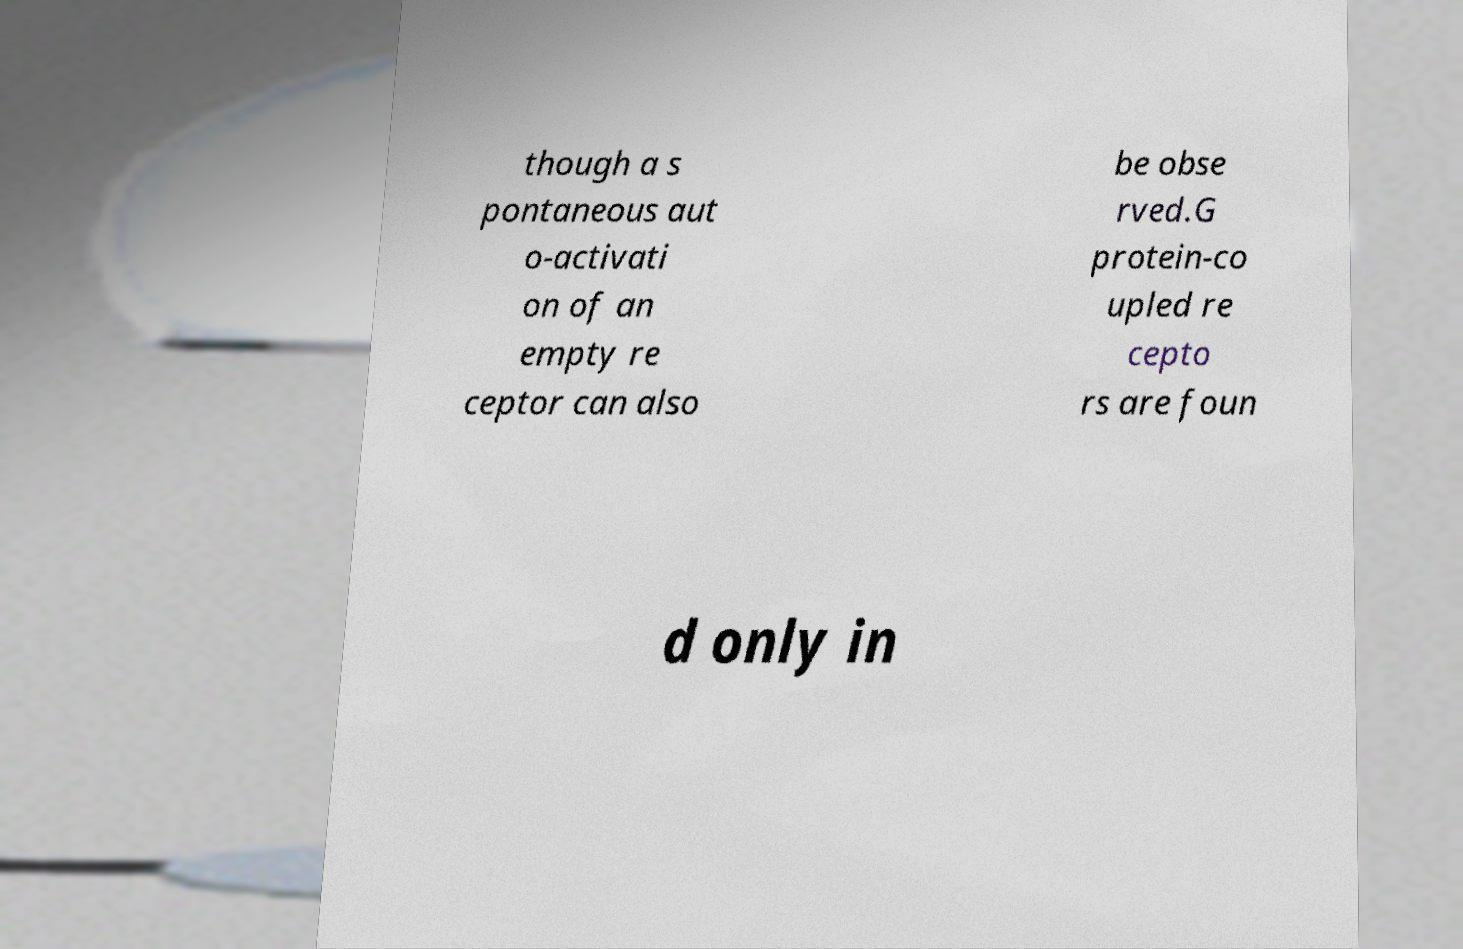What messages or text are displayed in this image? I need them in a readable, typed format. though a s pontaneous aut o-activati on of an empty re ceptor can also be obse rved.G protein-co upled re cepto rs are foun d only in 